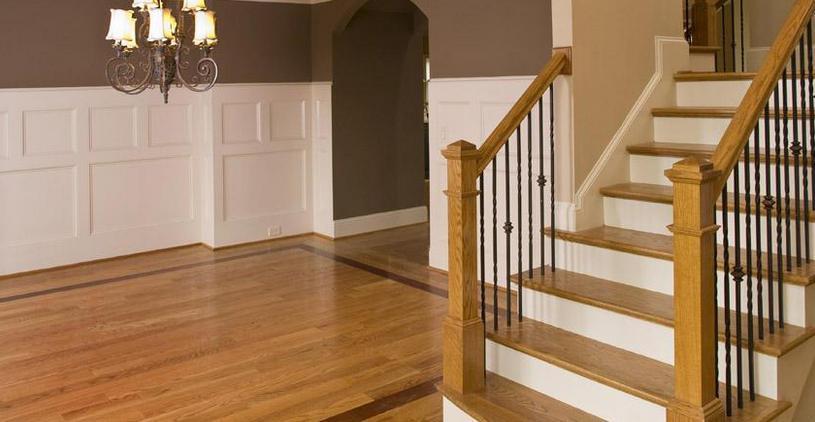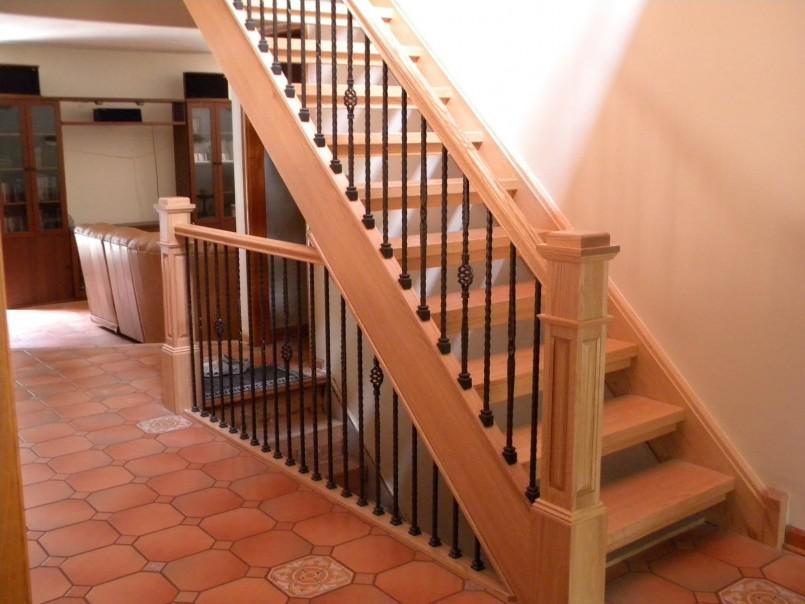The first image is the image on the left, the second image is the image on the right. Analyze the images presented: Is the assertion "One image features a staircase that takes a turn to the right and has dark rails with vertical wrought iron bars accented with circle shapes." valid? Answer yes or no. No. The first image is the image on the left, the second image is the image on the right. For the images shown, is this caption "One of the railings is white." true? Answer yes or no. No. 